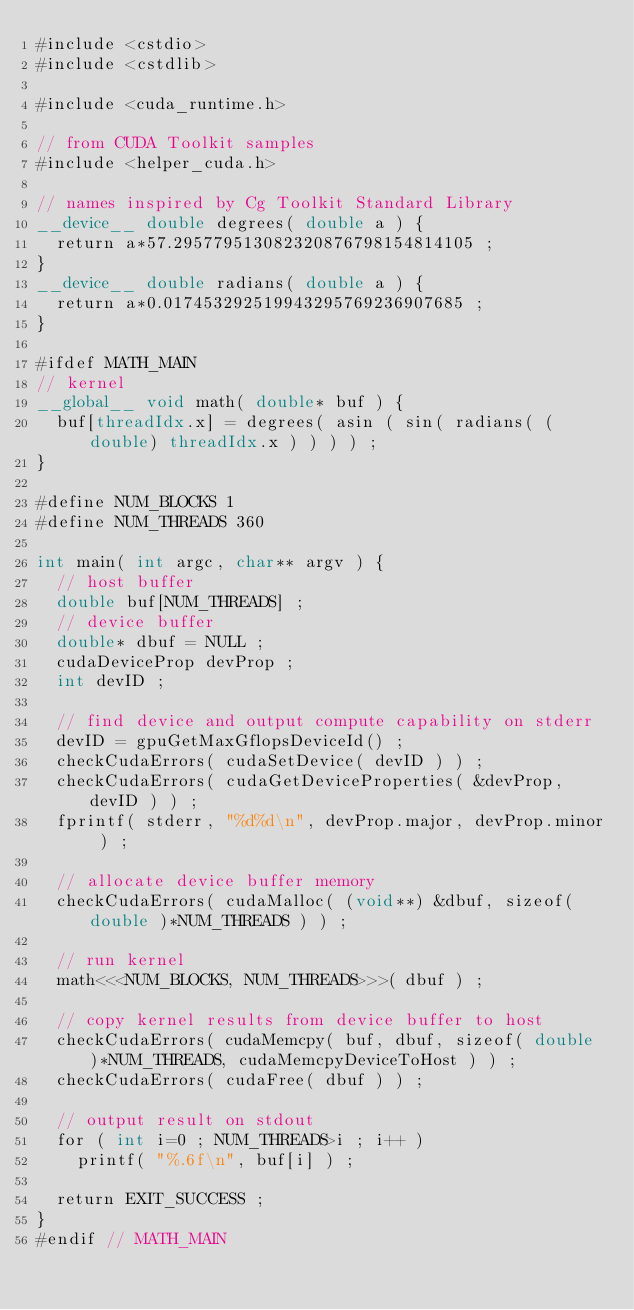<code> <loc_0><loc_0><loc_500><loc_500><_Cuda_>#include <cstdio>
#include <cstdlib>

#include <cuda_runtime.h>

// from CUDA Toolkit samples
#include <helper_cuda.h>

// names inspired by Cg Toolkit Standard Library
__device__ double degrees( double a ) {
	return a*57.295779513082320876798154814105 ;
}
__device__ double radians( double a ) {
	return a*0.017453292519943295769236907685 ;
}

#ifdef MATH_MAIN
// kernel
__global__ void math( double* buf ) {
	buf[threadIdx.x] = degrees( asin ( sin( radians( (double) threadIdx.x ) ) ) ) ;
}

#define NUM_BLOCKS 1
#define NUM_THREADS 360

int main( int argc, char** argv ) {
	// host buffer
	double buf[NUM_THREADS] ;
	// device buffer
	double* dbuf = NULL ;
	cudaDeviceProp devProp ;
	int devID ;

	// find device and output compute capability on stderr
	devID = gpuGetMaxGflopsDeviceId() ;
	checkCudaErrors( cudaSetDevice( devID ) ) ;
	checkCudaErrors( cudaGetDeviceProperties( &devProp, devID ) ) ;
	fprintf( stderr, "%d%d\n", devProp.major, devProp.minor ) ;

	// allocate device buffer memory
	checkCudaErrors( cudaMalloc( (void**) &dbuf, sizeof( double )*NUM_THREADS ) ) ;

	// run kernel
	math<<<NUM_BLOCKS, NUM_THREADS>>>( dbuf ) ;

	// copy kernel results from device buffer to host
	checkCudaErrors( cudaMemcpy( buf, dbuf, sizeof( double )*NUM_THREADS, cudaMemcpyDeviceToHost ) ) ;
	checkCudaErrors( cudaFree( dbuf ) ) ;

	// output result on stdout
	for ( int i=0 ; NUM_THREADS>i ; i++ )
		printf( "%.6f\n", buf[i] ) ;

	return EXIT_SUCCESS ;
}
#endif // MATH_MAIN
</code> 